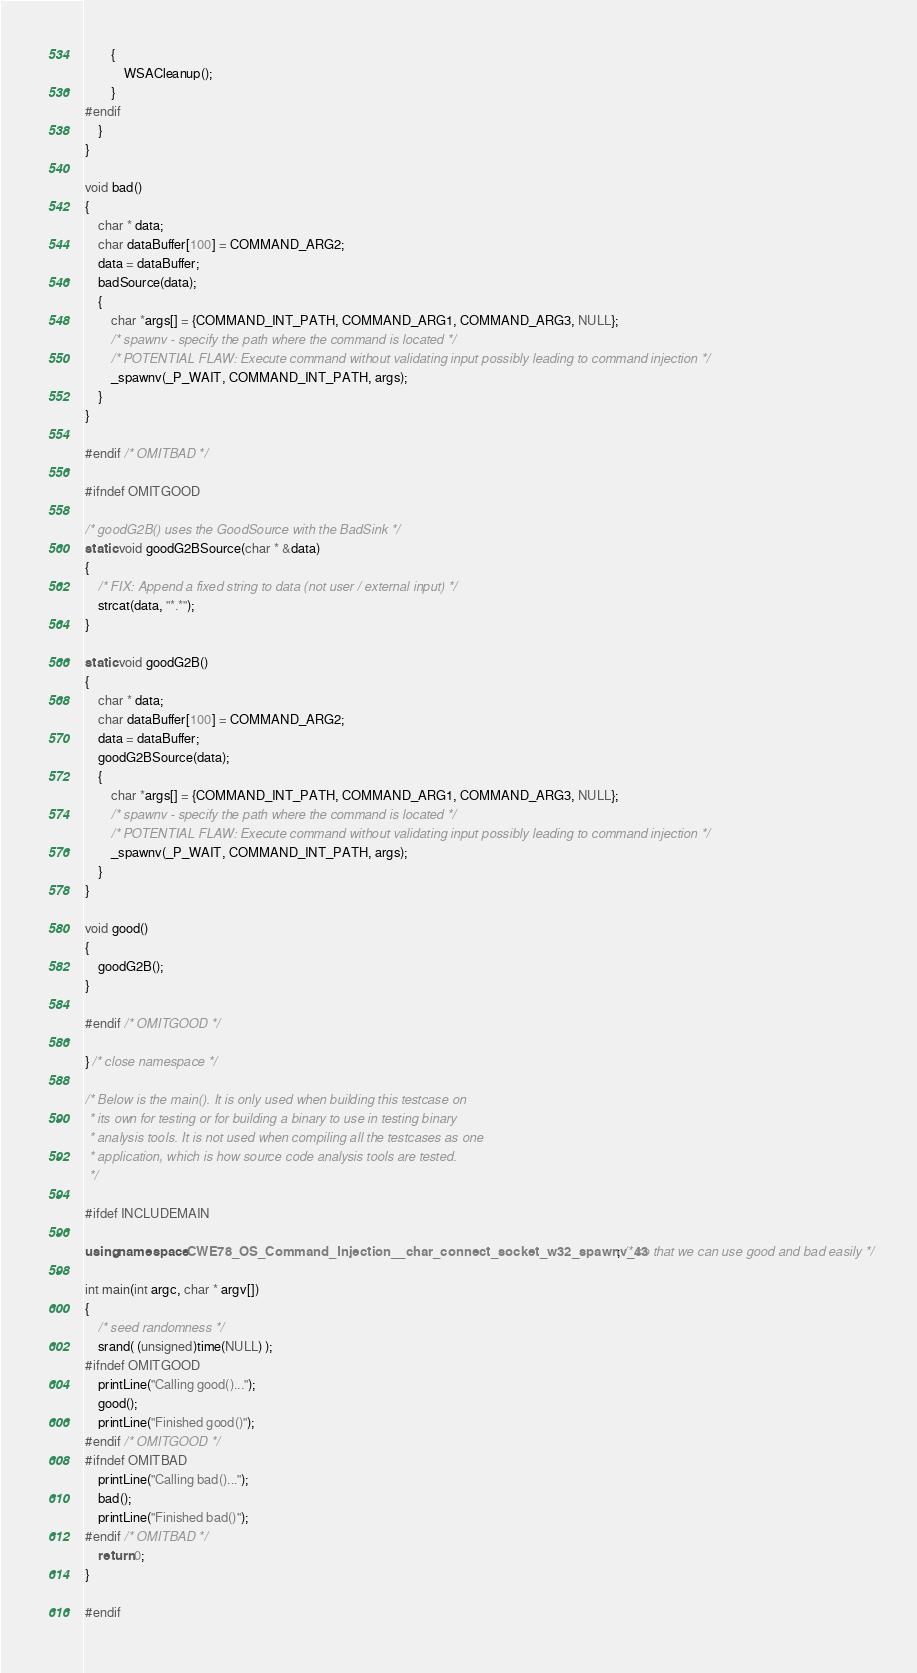Convert code to text. <code><loc_0><loc_0><loc_500><loc_500><_C++_>        {
            WSACleanup();
        }
#endif
    }
}

void bad()
{
    char * data;
    char dataBuffer[100] = COMMAND_ARG2;
    data = dataBuffer;
    badSource(data);
    {
        char *args[] = {COMMAND_INT_PATH, COMMAND_ARG1, COMMAND_ARG3, NULL};
        /* spawnv - specify the path where the command is located */
        /* POTENTIAL FLAW: Execute command without validating input possibly leading to command injection */
        _spawnv(_P_WAIT, COMMAND_INT_PATH, args);
    }
}

#endif /* OMITBAD */

#ifndef OMITGOOD

/* goodG2B() uses the GoodSource with the BadSink */
static void goodG2BSource(char * &data)
{
    /* FIX: Append a fixed string to data (not user / external input) */
    strcat(data, "*.*");
}

static void goodG2B()
{
    char * data;
    char dataBuffer[100] = COMMAND_ARG2;
    data = dataBuffer;
    goodG2BSource(data);
    {
        char *args[] = {COMMAND_INT_PATH, COMMAND_ARG1, COMMAND_ARG3, NULL};
        /* spawnv - specify the path where the command is located */
        /* POTENTIAL FLAW: Execute command without validating input possibly leading to command injection */
        _spawnv(_P_WAIT, COMMAND_INT_PATH, args);
    }
}

void good()
{
    goodG2B();
}

#endif /* OMITGOOD */

} /* close namespace */

/* Below is the main(). It is only used when building this testcase on
 * its own for testing or for building a binary to use in testing binary
 * analysis tools. It is not used when compiling all the testcases as one
 * application, which is how source code analysis tools are tested.
 */

#ifdef INCLUDEMAIN

using namespace CWE78_OS_Command_Injection__char_connect_socket_w32_spawnv_43; /* so that we can use good and bad easily */

int main(int argc, char * argv[])
{
    /* seed randomness */
    srand( (unsigned)time(NULL) );
#ifndef OMITGOOD
    printLine("Calling good()...");
    good();
    printLine("Finished good()");
#endif /* OMITGOOD */
#ifndef OMITBAD
    printLine("Calling bad()...");
    bad();
    printLine("Finished bad()");
#endif /* OMITBAD */
    return 0;
}

#endif
</code> 